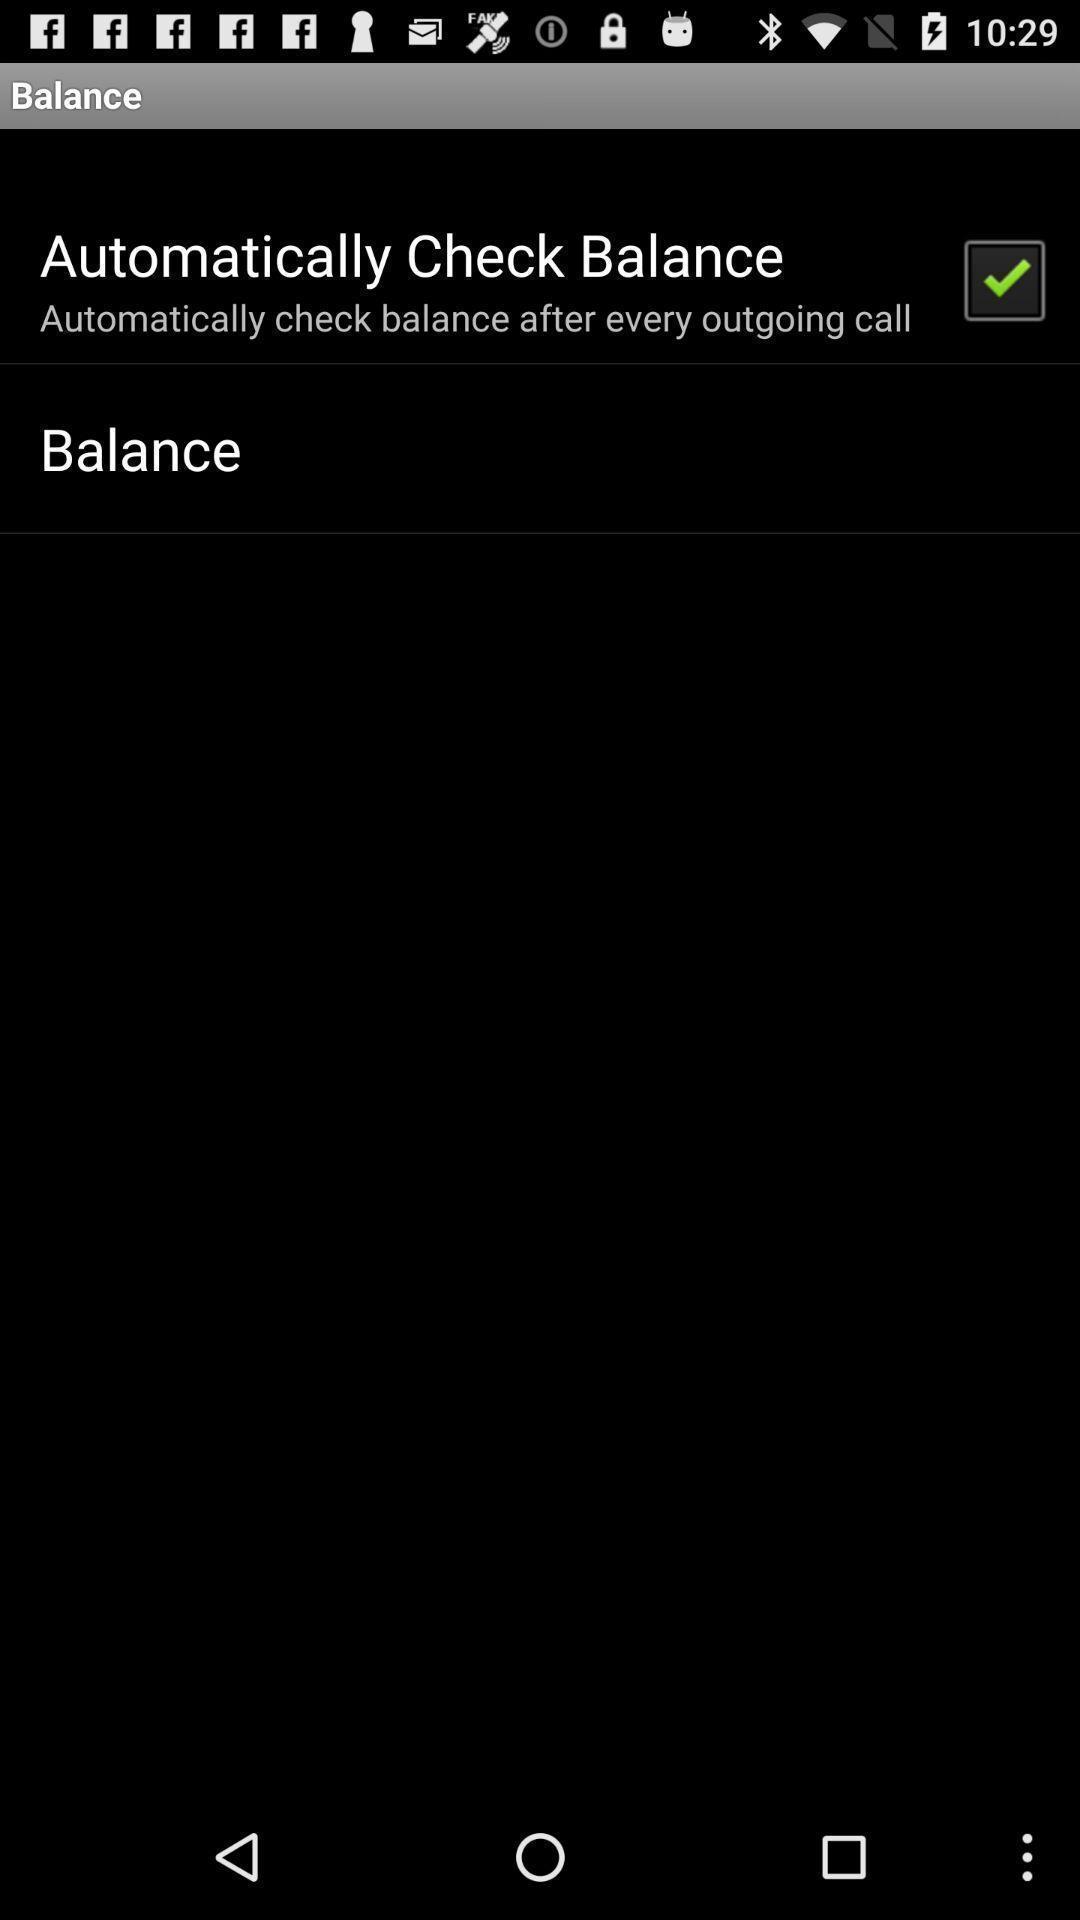Tell me about the visual elements in this screen capture. Page displaying to automatically check balance. 